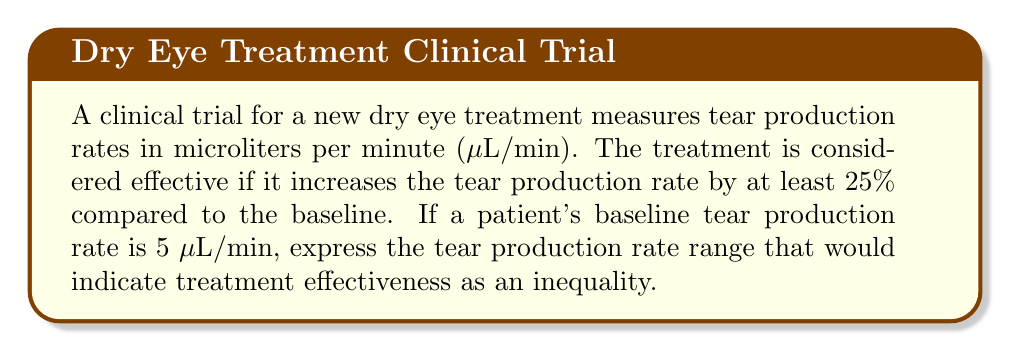Solve this math problem. Let's approach this step-by-step:

1) The baseline tear production rate is 5 µL/min.

2) For the treatment to be effective, it needs to increase the tear production rate by at least 25%.

3) To calculate the minimum effective rate:
   $$\text{Minimum effective rate} = \text{Baseline rate} + (25\% \times \text{Baseline rate})$$
   $$= 5 + (0.25 \times 5)$$
   $$= 5 + 1.25 = 6.25 \text{ µL/min}$$

4) The tear production rate needs to be greater than or equal to this minimum effective rate.

5) We can express this as an inequality:
   $$x \geq 6.25$$
   where $x$ represents the post-treatment tear production rate in µL/min.

6) There is no upper limit specified, so the inequality only has a lower bound.

Therefore, the range of tear production rates indicating treatment effectiveness can be expressed as $x \geq 6.25$, where $x$ is the post-treatment tear production rate in µL/min.
Answer: $x \geq 6.25$, where $x$ is the post-treatment tear production rate in µL/min 